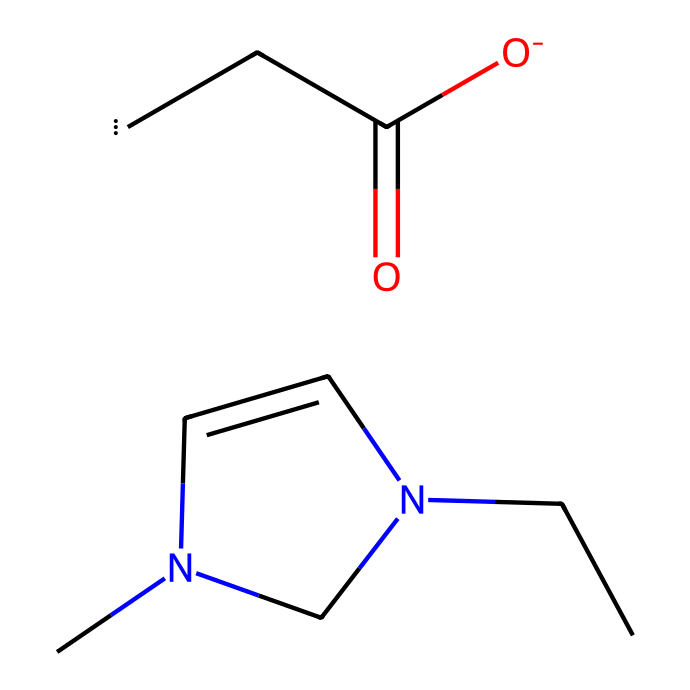What is the molecular formula of this ionic liquid? Analyzing the provided SMILES representation, we can identify the number of each type of atom present: C (carbon), H (hydrogen), N (nitrogen), and O (oxygen). Counting the elements, we find 10 carbons, 16 hydrogens, 2 nitrogens, and 2 oxygens, leading to the molecular formula C10H16N2O2.
Answer: C10H16N2O2 How many nitrogen atoms are in 1-ethyl-3-methylimidazolium acetate? By examining the structure through the SMILES, we can identify that there are two instances of nitrogen atoms represented within the imidazolium ring, which confirms the presence of two nitrogen atoms.
Answer: 2 What type of bond connects the nitrogen and carbon in the imidazolium ring? Looking at the structural representation, the nitrogen atoms are bonded to the carbon atoms through single covalent bonds that are characteristic in organic structures, specifically in imidazolium compounds.
Answer: single bond Which functional group does the acetate part of the ionic liquid belong to? The acetate portion is characterized by the presence of the carbonyl (C=O) and the hydroxyl (O–H) group, which identifies it distinctly as an acetate functional group, a common feature in carboxylic acids.
Answer: acetate Why is this chemical classified as an ionic liquid? The classification hinges on the presence of the imidazolium cation and acetate anion, which result in a low melting point and liquid state at room temperature, a defining characteristic of ionic liquids.
Answer: ionic liquid How does the structure of 1-ethyl-3-methylimidazolium acetate facilitate cellulose dissolution? The ionic interactions between the cation and cellulose, along with the polar nature of the acetate anion, enhance the solubility of cellulose in the ionic liquid, enabling it to effectively dissolve the polymer for material processing.
Answer: enhances solubility 